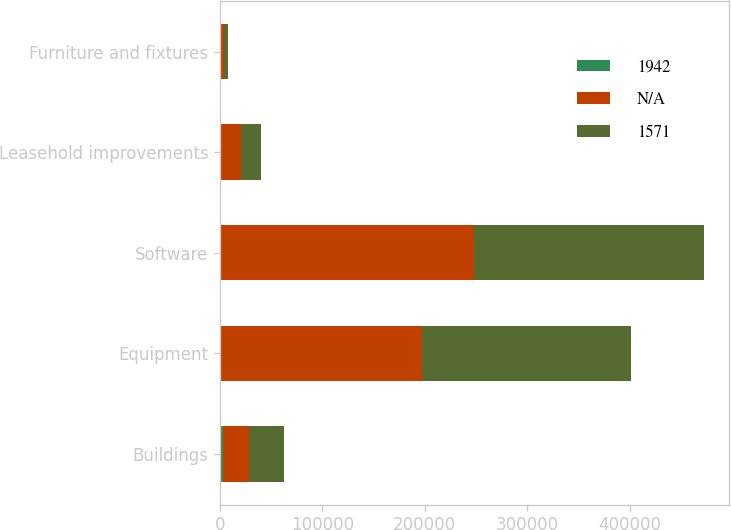Convert chart to OTSL. <chart><loc_0><loc_0><loc_500><loc_500><stacked_bar_chart><ecel><fcel>Buildings<fcel>Equipment<fcel>Software<fcel>Leasehold improvements<fcel>Furniture and fixtures<nl><fcel>1942<fcel>2530<fcel>210<fcel>210<fcel>315<fcel>37<nl><fcel>nan<fcel>26236<fcel>197186<fcel>248137<fcel>20458<fcel>3705<nl><fcel>1571<fcel>33996<fcel>204102<fcel>224766<fcel>19399<fcel>3809<nl></chart> 